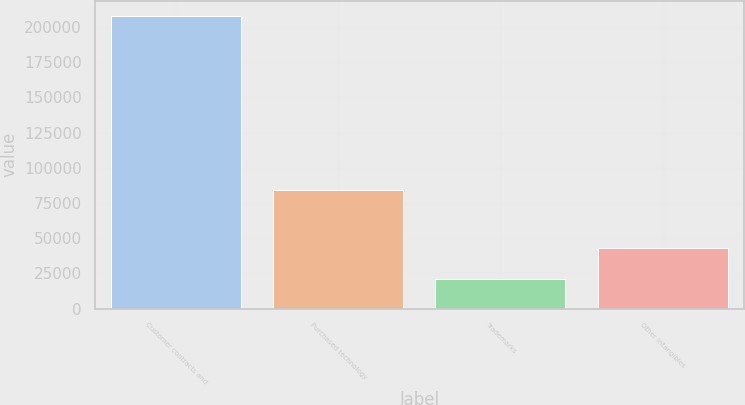Convert chart. <chart><loc_0><loc_0><loc_500><loc_500><bar_chart><fcel>Customer contracts and<fcel>Purchased technology<fcel>Trademarks<fcel>Other intangibles<nl><fcel>208000<fcel>84200<fcel>21100<fcel>43400<nl></chart> 